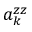<formula> <loc_0><loc_0><loc_500><loc_500>a _ { k } ^ { z z }</formula> 